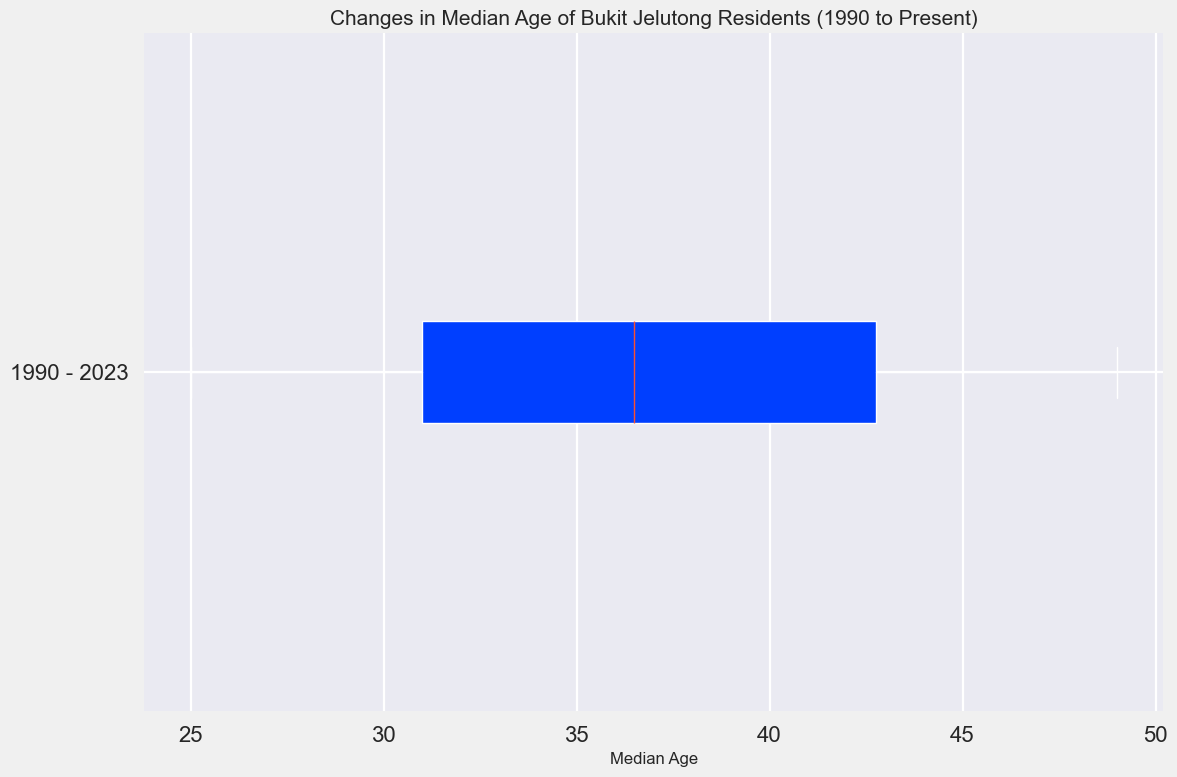What is the median age of Bukit Jelutong residents in 2023? To find the median age for a specific year, locate the corresponding data point on the plot. In this case, refer to 2023.
Answer: 49 What is the median age range covered in the box plot? The range of the median age in a box plot is determined by the minimum and maximum values of the box. Identify these values from the plot.
Answer: 25 to 49 How much did the median age increase from 1990 to 2023? To find the increase, subtract the median age in 1990 from the median age in 2023. From the data: 49 (2023) - 25 (1990) = 24.
Answer: 24 Is the distribution of median ages skewed, and if so, in which direction? In a box plot, skewness is indicated by the position of the median within the box and the length of the whiskers. Here, the median is closer to the lower quartile and the upper whisker is longer, indicating a right skew.
Answer: Right What is the interquartile range (IQR) of the median ages? The IQR is the difference between the 75th percentile (upper quartile) and the 25th percentile (lower quartile). Identify these values from the plot and subtract.
Answer: 20 (approximate) Compare the start of the whisker (minimum) and the end of the whisker (maximum) in the box plot. Which value has the greater spread? The minimum and maximum whisker values represent the spread of the data. Analyze the respective annotations on the box plot to compare the spread.
Answer: Maximum What can be inferred about the population of Bukit Jelutong residents over the years, based on the median ages shown in the plot? The box plot shows a steady increase in median ages from 1990 to 2023, indicating that the population is aging over time, likely due to residents aging in place.
Answer: Increasing aging population How many years saw a median age of over 40? To determine this, count how many data points in the plot exceed the median age of 40. Identify the years beyond this median age from the x-axis.
Answer: 14 (2010 to 2023) 